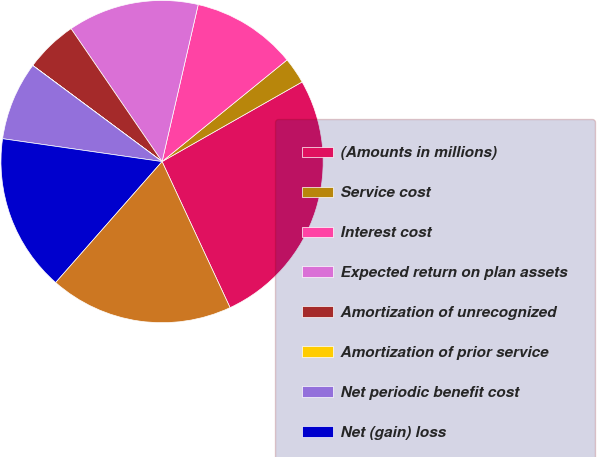Convert chart to OTSL. <chart><loc_0><loc_0><loc_500><loc_500><pie_chart><fcel>(Amounts in millions)<fcel>Service cost<fcel>Interest cost<fcel>Expected return on plan assets<fcel>Amortization of unrecognized<fcel>Amortization of prior service<fcel>Net periodic benefit cost<fcel>Net (gain) loss<fcel>Total recognized in OCI<nl><fcel>26.3%<fcel>2.64%<fcel>10.53%<fcel>13.16%<fcel>5.27%<fcel>0.01%<fcel>7.9%<fcel>15.79%<fcel>18.42%<nl></chart> 